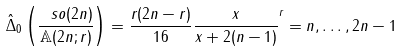<formula> <loc_0><loc_0><loc_500><loc_500>\hat { \Delta } _ { 0 } \left ( \frac { \ s o ( 2 n ) } { \mathbb { A } ( 2 n ; r ) } \right ) = \frac { r ( 2 n - r ) } { 1 6 } \frac { x } { x + 2 ( n - 1 ) } ^ { r } = n , \dots , 2 n - 1</formula> 